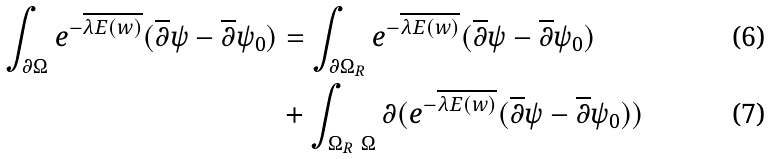<formula> <loc_0><loc_0><loc_500><loc_500>\int _ { \partial \Omega } e ^ { - \overline { \lambda E ( w ) } } ( \overline { \partial } \psi - \overline { \partial } \psi _ { 0 } ) & = \int _ { \partial \Omega _ { R } } e ^ { - \overline { \lambda E ( w ) } } ( \overline { \partial } \psi - \overline { \partial } \psi _ { 0 } ) \\ & + \int _ { \Omega _ { R } \ \Omega } \partial ( e ^ { - \overline { \lambda E ( w ) } } ( \overline { \partial } \psi - \overline { \partial } \psi _ { 0 } ) )</formula> 